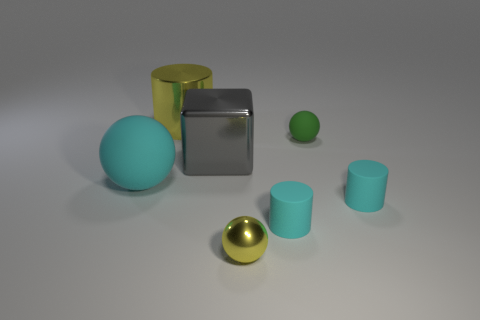What is the size of the other metal thing that is the same color as the tiny shiny thing?
Your answer should be compact. Large. What shape is the thing that is the same color as the metal cylinder?
Ensure brevity in your answer.  Sphere. What is the shape of the big object that is made of the same material as the green ball?
Ensure brevity in your answer.  Sphere. Is there any other thing of the same color as the tiny shiny sphere?
Your response must be concise. Yes. Does the metallic cylinder have the same color as the matte sphere to the left of the small metallic object?
Your response must be concise. No. Is the number of large metal objects that are behind the small metal sphere less than the number of small yellow metal spheres?
Ensure brevity in your answer.  No. There is a tiny cyan thing that is right of the green rubber thing; what material is it?
Provide a succinct answer. Rubber. What number of other objects are the same size as the gray block?
Give a very brief answer. 2. Is the size of the gray block the same as the rubber sphere in front of the shiny block?
Keep it short and to the point. Yes. The small cyan matte object that is left of the sphere behind the rubber sphere in front of the gray cube is what shape?
Make the answer very short. Cylinder. 